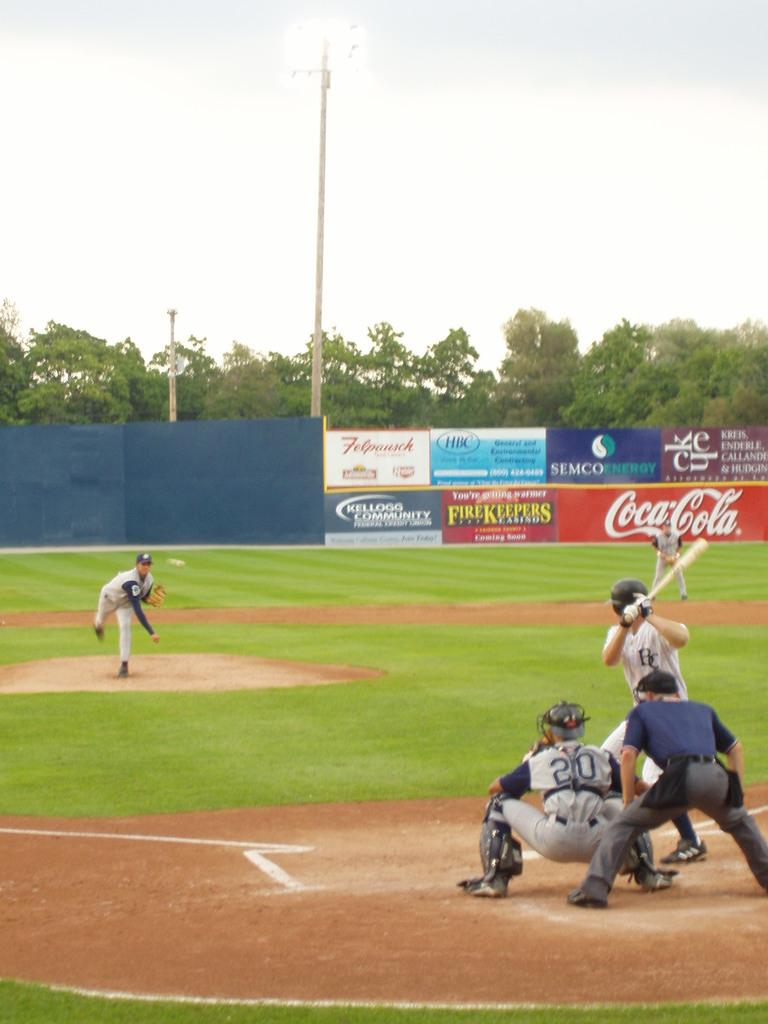<image>
Offer a succinct explanation of the picture presented. CocaCola is one of the sponsors lining the outfield walls of this baseball stadium. 